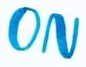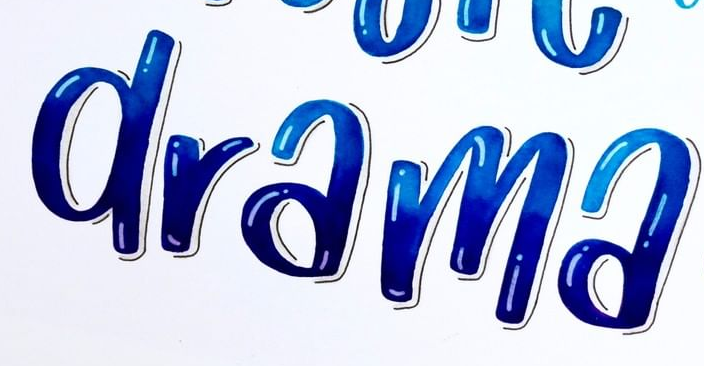What words can you see in these images in sequence, separated by a semicolon? ON; drama 